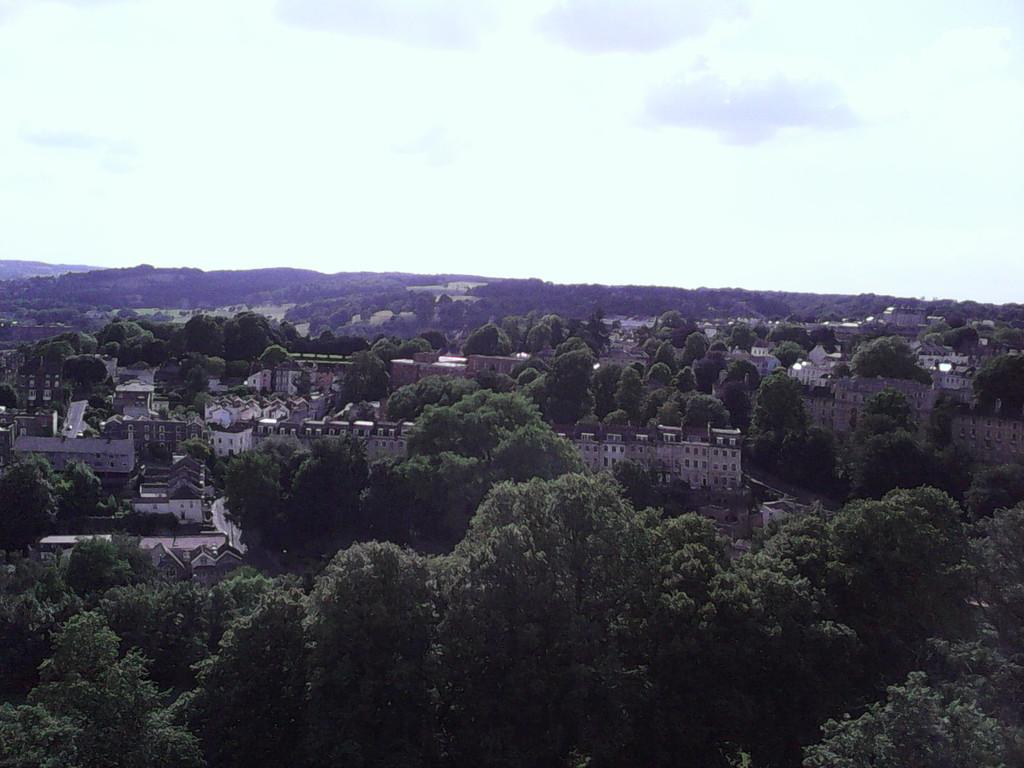What type of natural elements can be seen in the image? There are trees in the image. What type of man-made structures are present in the image? There are buildings in the image. What can be seen in the sky in the background of the image? There are clouds visible in the background of the image. What type of garden can be seen in the image? There is no garden present in the image; it features trees and buildings. What type of destruction can be seen in the image? There is no destruction present in the image; it features trees, buildings, and clouds. 